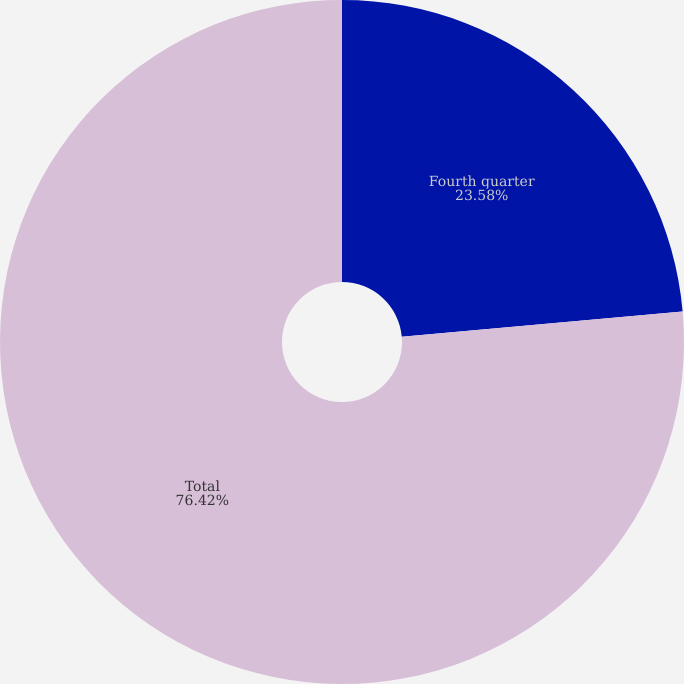Convert chart to OTSL. <chart><loc_0><loc_0><loc_500><loc_500><pie_chart><fcel>Fourth quarter<fcel>Total<nl><fcel>23.58%<fcel>76.42%<nl></chart> 